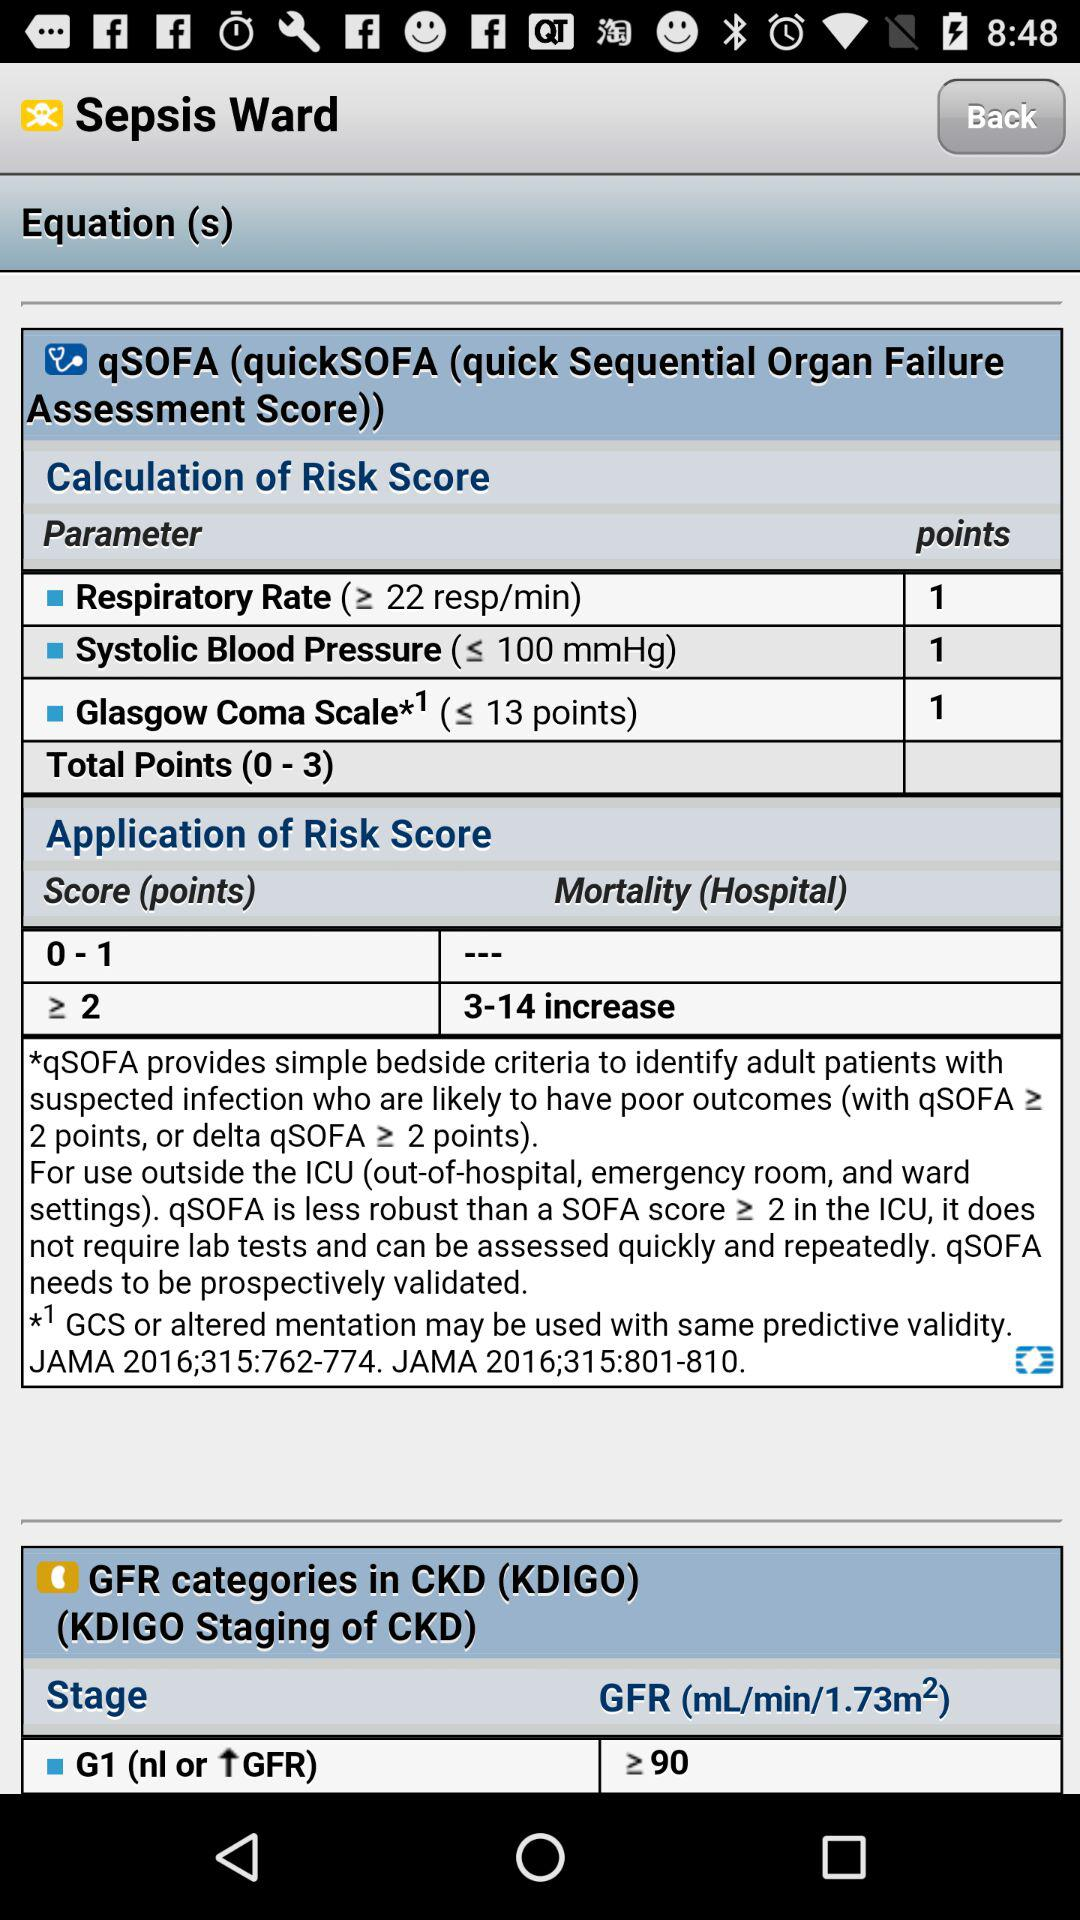How many Glasgow coma scale points are there? There is 1 point. 